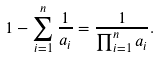<formula> <loc_0><loc_0><loc_500><loc_500>1 - \sum _ { i = 1 } ^ { n } \frac { 1 } { a _ { i } } = \frac { 1 } { \prod _ { i = 1 } ^ { n } a _ { i } } .</formula> 